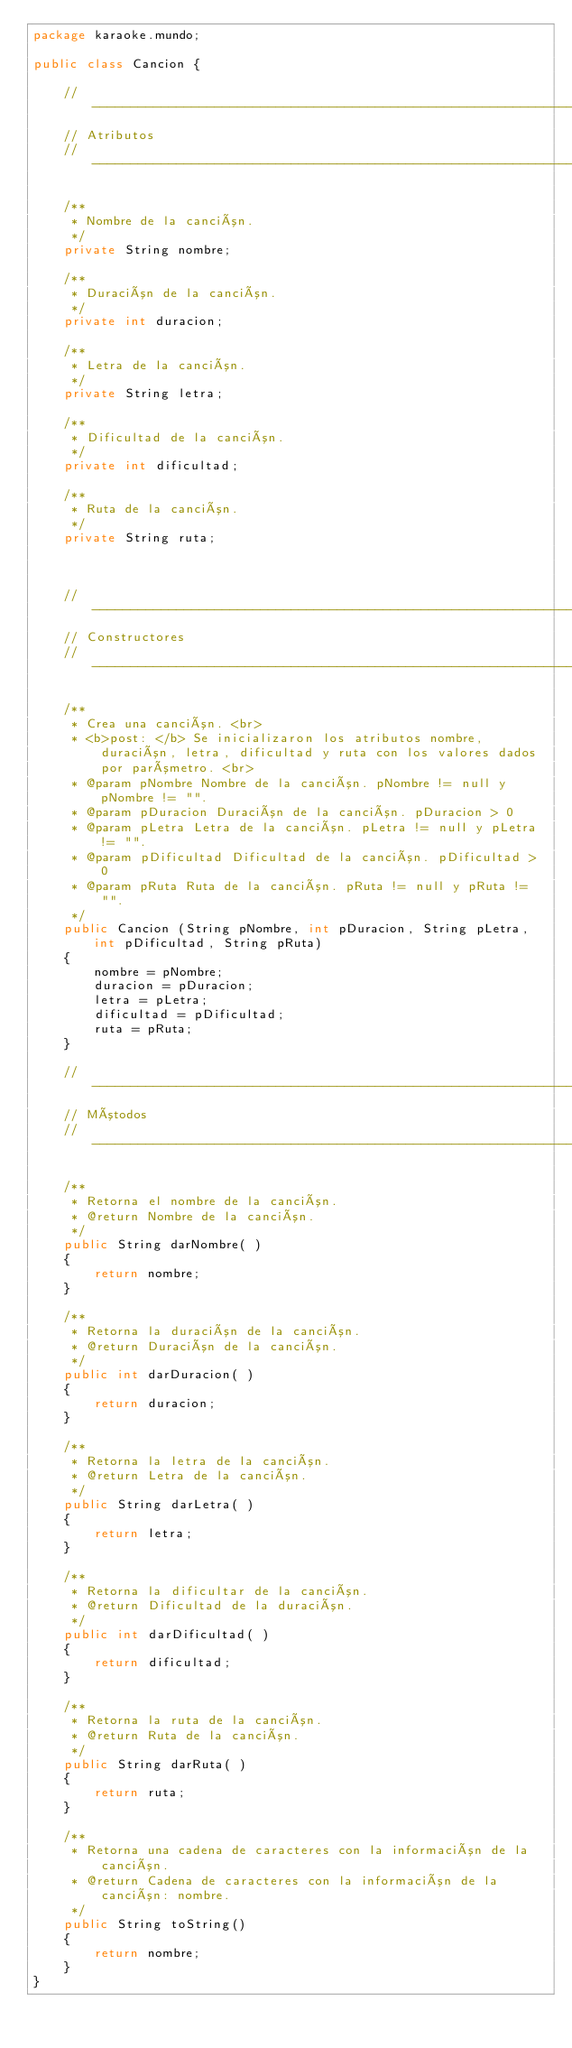<code> <loc_0><loc_0><loc_500><loc_500><_Java_>package karaoke.mundo;

public class Cancion {

    // -----------------------------------------------------------------
    // Atributos
    // -----------------------------------------------------------------

    /**
     * Nombre de la canción.
     */
    private String nombre;
    
    /**
     * Duración de la canción.
     */
    private int duracion;
    
    /**
     * Letra de la canción.
     */
    private String letra;
    
    /**
     * Dificultad de la canción.
     */
    private int dificultad;
    
    /**
     * Ruta de la canción.
     */
    private String ruta;
    
    
    
    // -----------------------------------------------------------------
    // Constructores
    // -----------------------------------------------------------------
    
    /**
     * Crea una canción. <br>
     * <b>post: </b> Se inicializaron los atributos nombre, duración, letra, dificultad y ruta con los valores dados por parómetro. <br>
     * @param pNombre Nombre de la canción. pNombre != null y pNombre != "".
     * @param pDuracion Duración de la canción. pDuracion > 0
     * @param pLetra Letra de la canción. pLetra != null y pLetra != "".
     * @param pDificultad Dificultad de la canción. pDificultad > 0
     * @param pRuta Ruta de la canción. pRuta != null y pRuta != "".
     */
    public Cancion (String pNombre, int pDuracion, String pLetra, int pDificultad, String pRuta)
    {
    	nombre = pNombre;
    	duracion = pDuracion;
    	letra = pLetra;
    	dificultad = pDificultad;
    	ruta = pRuta;
    }
    
    // -----------------------------------------------------------------
    // Mótodos
    // -----------------------------------------------------------------

    /**
     * Retorna el nombre de la canción.
     * @return Nombre de la canción.
     */
    public String darNombre( )
    {
        return nombre;
    }
    
    /**
     * Retorna la duración de la canción.
     * @return Duración de la canción.
     */
    public int darDuracion( )
    {
        return duracion;
    }
    
    /**
     * Retorna la letra de la canción.
     * @return Letra de la canción.
     */
    public String darLetra( )
    {
        return letra;
    }
    
    /**
     * Retorna la dificultar de la canción.
     * @return Dificultad de la duración.
     */
    public int darDificultad( )
    {
        return dificultad;
    }
    
    /**
     * Retorna la ruta de la canción.
     * @return Ruta de la canción.
     */
    public String darRuta( )
    {
        return ruta;
    }
	
    /**
     * Retorna una cadena de caracteres con la información de la canción.
     * @return Cadena de caracteres con la información de la canción: nombre.
     */
    public String toString()
    {
    	return nombre;
    }
}
</code> 